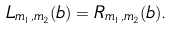Convert formula to latex. <formula><loc_0><loc_0><loc_500><loc_500>L _ { m _ { 1 } , m _ { 2 } } ( b ) = R _ { m _ { 1 } , m _ { 2 } } ( b ) .</formula> 